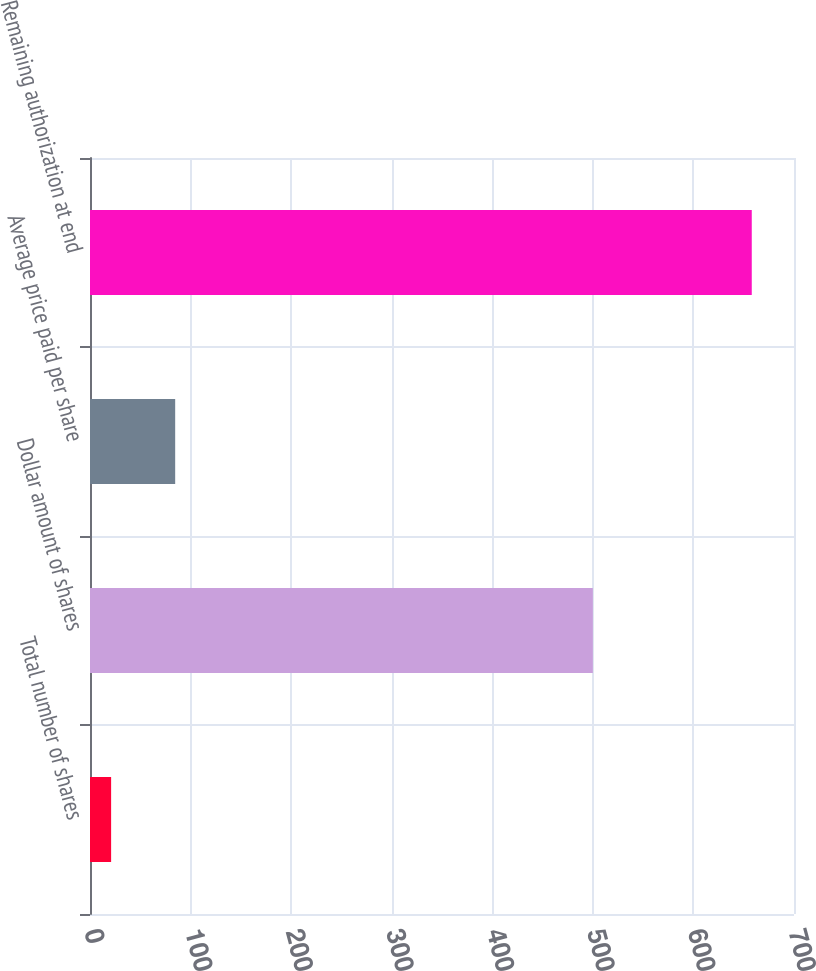<chart> <loc_0><loc_0><loc_500><loc_500><bar_chart><fcel>Total number of shares<fcel>Dollar amount of shares<fcel>Average price paid per share<fcel>Remaining authorization at end<nl><fcel>21<fcel>500<fcel>84.7<fcel>658<nl></chart> 